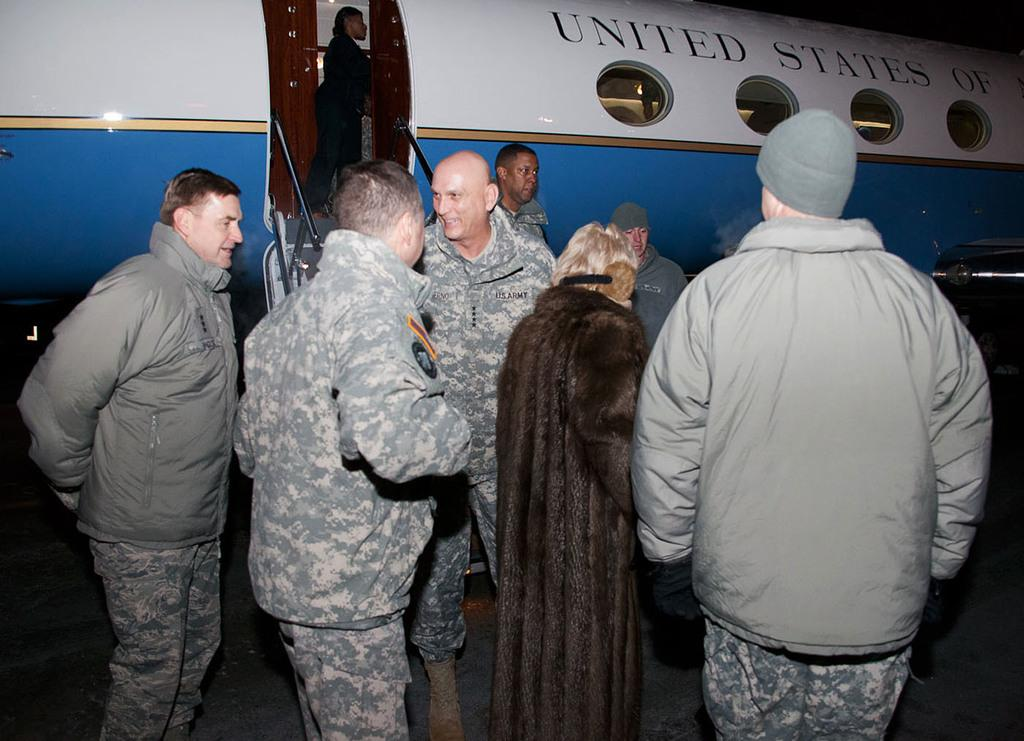What is the main subject of the image? The main subject of the image is a plane. What else can be seen in the image besides the plane? There are stairs and people visible in the image. How would you describe the lighting in the image? The image is slightly dark. What type of ring can be seen on the plane's wing in the image? There is no ring present on the plane's wing in the image. 